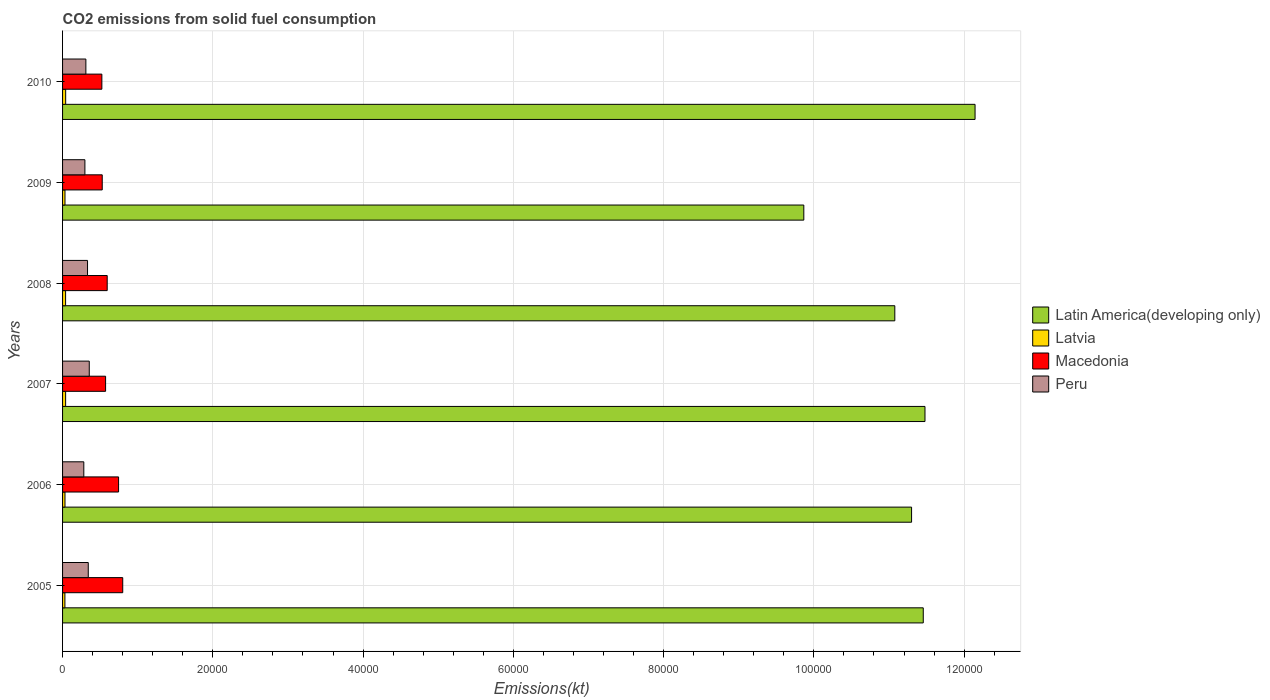How many different coloured bars are there?
Give a very brief answer. 4. Are the number of bars per tick equal to the number of legend labels?
Give a very brief answer. Yes. Are the number of bars on each tick of the Y-axis equal?
Provide a short and direct response. Yes. How many bars are there on the 1st tick from the top?
Your response must be concise. 4. What is the label of the 4th group of bars from the top?
Your answer should be compact. 2007. What is the amount of CO2 emitted in Latin America(developing only) in 2009?
Your answer should be very brief. 9.87e+04. Across all years, what is the maximum amount of CO2 emitted in Peru?
Offer a terse response. 3553.32. Across all years, what is the minimum amount of CO2 emitted in Peru?
Ensure brevity in your answer.  2827.26. In which year was the amount of CO2 emitted in Latin America(developing only) maximum?
Make the answer very short. 2010. What is the total amount of CO2 emitted in Peru in the graph?
Make the answer very short. 1.92e+04. What is the difference between the amount of CO2 emitted in Latin America(developing only) in 2005 and that in 2009?
Give a very brief answer. 1.59e+04. What is the difference between the amount of CO2 emitted in Macedonia in 2010 and the amount of CO2 emitted in Latvia in 2009?
Your response must be concise. 4906.45. What is the average amount of CO2 emitted in Latin America(developing only) per year?
Provide a succinct answer. 1.12e+05. In the year 2005, what is the difference between the amount of CO2 emitted in Latvia and amount of CO2 emitted in Latin America(developing only)?
Ensure brevity in your answer.  -1.14e+05. What is the ratio of the amount of CO2 emitted in Latvia in 2005 to that in 2006?
Keep it short and to the point. 0.97. Is the amount of CO2 emitted in Latin America(developing only) in 2006 less than that in 2009?
Your answer should be very brief. No. What is the difference between the highest and the second highest amount of CO2 emitted in Latin America(developing only)?
Ensure brevity in your answer.  6665.47. What is the difference between the highest and the lowest amount of CO2 emitted in Latvia?
Keep it short and to the point. 102.68. Is the sum of the amount of CO2 emitted in Latin America(developing only) in 2006 and 2009 greater than the maximum amount of CO2 emitted in Peru across all years?
Your response must be concise. Yes. Is it the case that in every year, the sum of the amount of CO2 emitted in Latvia and amount of CO2 emitted in Latin America(developing only) is greater than the sum of amount of CO2 emitted in Peru and amount of CO2 emitted in Macedonia?
Keep it short and to the point. No. What does the 4th bar from the top in 2009 represents?
Provide a short and direct response. Latin America(developing only). What does the 2nd bar from the bottom in 2009 represents?
Your answer should be compact. Latvia. Is it the case that in every year, the sum of the amount of CO2 emitted in Latin America(developing only) and amount of CO2 emitted in Macedonia is greater than the amount of CO2 emitted in Latvia?
Your answer should be compact. Yes. Are the values on the major ticks of X-axis written in scientific E-notation?
Give a very brief answer. No. Does the graph contain any zero values?
Give a very brief answer. No. How are the legend labels stacked?
Your answer should be compact. Vertical. What is the title of the graph?
Keep it short and to the point. CO2 emissions from solid fuel consumption. What is the label or title of the X-axis?
Offer a terse response. Emissions(kt). What is the Emissions(kt) in Latin America(developing only) in 2005?
Give a very brief answer. 1.15e+05. What is the Emissions(kt) of Latvia in 2005?
Your response must be concise. 311.69. What is the Emissions(kt) in Macedonia in 2005?
Provide a succinct answer. 8008.73. What is the Emissions(kt) of Peru in 2005?
Make the answer very short. 3421.31. What is the Emissions(kt) of Latin America(developing only) in 2006?
Provide a short and direct response. 1.13e+05. What is the Emissions(kt) in Latvia in 2006?
Give a very brief answer. 322.7. What is the Emissions(kt) in Macedonia in 2006?
Keep it short and to the point. 7455.01. What is the Emissions(kt) in Peru in 2006?
Your answer should be very brief. 2827.26. What is the Emissions(kt) of Latin America(developing only) in 2007?
Provide a short and direct response. 1.15e+05. What is the Emissions(kt) of Latvia in 2007?
Offer a very short reply. 407.04. What is the Emissions(kt) of Macedonia in 2007?
Your answer should be compact. 5727.85. What is the Emissions(kt) of Peru in 2007?
Ensure brevity in your answer.  3553.32. What is the Emissions(kt) of Latin America(developing only) in 2008?
Keep it short and to the point. 1.11e+05. What is the Emissions(kt) of Latvia in 2008?
Keep it short and to the point. 403.37. What is the Emissions(kt) in Macedonia in 2008?
Make the answer very short. 5940.54. What is the Emissions(kt) in Peru in 2008?
Offer a terse response. 3322.3. What is the Emissions(kt) of Latin America(developing only) in 2009?
Keep it short and to the point. 9.87e+04. What is the Emissions(kt) of Latvia in 2009?
Offer a very short reply. 322.7. What is the Emissions(kt) of Macedonia in 2009?
Keep it short and to the point. 5280.48. What is the Emissions(kt) of Peru in 2009?
Offer a very short reply. 2973.94. What is the Emissions(kt) of Latin America(developing only) in 2010?
Ensure brevity in your answer.  1.21e+05. What is the Emissions(kt) in Latvia in 2010?
Provide a short and direct response. 414.37. What is the Emissions(kt) of Macedonia in 2010?
Offer a terse response. 5229.14. What is the Emissions(kt) in Peru in 2010?
Keep it short and to the point. 3102.28. Across all years, what is the maximum Emissions(kt) in Latin America(developing only)?
Ensure brevity in your answer.  1.21e+05. Across all years, what is the maximum Emissions(kt) of Latvia?
Make the answer very short. 414.37. Across all years, what is the maximum Emissions(kt) of Macedonia?
Your answer should be very brief. 8008.73. Across all years, what is the maximum Emissions(kt) of Peru?
Offer a very short reply. 3553.32. Across all years, what is the minimum Emissions(kt) in Latin America(developing only)?
Keep it short and to the point. 9.87e+04. Across all years, what is the minimum Emissions(kt) in Latvia?
Make the answer very short. 311.69. Across all years, what is the minimum Emissions(kt) of Macedonia?
Offer a very short reply. 5229.14. Across all years, what is the minimum Emissions(kt) of Peru?
Your response must be concise. 2827.26. What is the total Emissions(kt) of Latin America(developing only) in the graph?
Give a very brief answer. 6.73e+05. What is the total Emissions(kt) of Latvia in the graph?
Keep it short and to the point. 2181.86. What is the total Emissions(kt) in Macedonia in the graph?
Offer a terse response. 3.76e+04. What is the total Emissions(kt) in Peru in the graph?
Keep it short and to the point. 1.92e+04. What is the difference between the Emissions(kt) of Latin America(developing only) in 2005 and that in 2006?
Keep it short and to the point. 1556.24. What is the difference between the Emissions(kt) of Latvia in 2005 and that in 2006?
Make the answer very short. -11. What is the difference between the Emissions(kt) in Macedonia in 2005 and that in 2006?
Keep it short and to the point. 553.72. What is the difference between the Emissions(kt) of Peru in 2005 and that in 2006?
Ensure brevity in your answer.  594.05. What is the difference between the Emissions(kt) in Latin America(developing only) in 2005 and that in 2007?
Your response must be concise. -227.8. What is the difference between the Emissions(kt) of Latvia in 2005 and that in 2007?
Offer a terse response. -95.34. What is the difference between the Emissions(kt) of Macedonia in 2005 and that in 2007?
Your response must be concise. 2280.87. What is the difference between the Emissions(kt) of Peru in 2005 and that in 2007?
Give a very brief answer. -132.01. What is the difference between the Emissions(kt) in Latin America(developing only) in 2005 and that in 2008?
Give a very brief answer. 3788.18. What is the difference between the Emissions(kt) of Latvia in 2005 and that in 2008?
Your response must be concise. -91.67. What is the difference between the Emissions(kt) of Macedonia in 2005 and that in 2008?
Make the answer very short. 2068.19. What is the difference between the Emissions(kt) in Peru in 2005 and that in 2008?
Keep it short and to the point. 99.01. What is the difference between the Emissions(kt) in Latin America(developing only) in 2005 and that in 2009?
Give a very brief answer. 1.59e+04. What is the difference between the Emissions(kt) in Latvia in 2005 and that in 2009?
Provide a succinct answer. -11. What is the difference between the Emissions(kt) in Macedonia in 2005 and that in 2009?
Provide a short and direct response. 2728.25. What is the difference between the Emissions(kt) of Peru in 2005 and that in 2009?
Keep it short and to the point. 447.37. What is the difference between the Emissions(kt) of Latin America(developing only) in 2005 and that in 2010?
Give a very brief answer. -6893.27. What is the difference between the Emissions(kt) of Latvia in 2005 and that in 2010?
Provide a succinct answer. -102.68. What is the difference between the Emissions(kt) in Macedonia in 2005 and that in 2010?
Provide a short and direct response. 2779.59. What is the difference between the Emissions(kt) in Peru in 2005 and that in 2010?
Provide a succinct answer. 319.03. What is the difference between the Emissions(kt) in Latin America(developing only) in 2006 and that in 2007?
Your answer should be compact. -1784.04. What is the difference between the Emissions(kt) in Latvia in 2006 and that in 2007?
Give a very brief answer. -84.34. What is the difference between the Emissions(kt) in Macedonia in 2006 and that in 2007?
Offer a very short reply. 1727.16. What is the difference between the Emissions(kt) in Peru in 2006 and that in 2007?
Provide a succinct answer. -726.07. What is the difference between the Emissions(kt) of Latin America(developing only) in 2006 and that in 2008?
Your response must be concise. 2231.94. What is the difference between the Emissions(kt) of Latvia in 2006 and that in 2008?
Your answer should be compact. -80.67. What is the difference between the Emissions(kt) in Macedonia in 2006 and that in 2008?
Keep it short and to the point. 1514.47. What is the difference between the Emissions(kt) in Peru in 2006 and that in 2008?
Your answer should be very brief. -495.05. What is the difference between the Emissions(kt) in Latin America(developing only) in 2006 and that in 2009?
Your answer should be very brief. 1.43e+04. What is the difference between the Emissions(kt) of Latvia in 2006 and that in 2009?
Your answer should be compact. 0. What is the difference between the Emissions(kt) in Macedonia in 2006 and that in 2009?
Make the answer very short. 2174.53. What is the difference between the Emissions(kt) of Peru in 2006 and that in 2009?
Provide a short and direct response. -146.68. What is the difference between the Emissions(kt) of Latin America(developing only) in 2006 and that in 2010?
Give a very brief answer. -8449.5. What is the difference between the Emissions(kt) of Latvia in 2006 and that in 2010?
Provide a short and direct response. -91.67. What is the difference between the Emissions(kt) in Macedonia in 2006 and that in 2010?
Ensure brevity in your answer.  2225.87. What is the difference between the Emissions(kt) in Peru in 2006 and that in 2010?
Provide a short and direct response. -275.02. What is the difference between the Emissions(kt) of Latin America(developing only) in 2007 and that in 2008?
Give a very brief answer. 4015.98. What is the difference between the Emissions(kt) in Latvia in 2007 and that in 2008?
Offer a terse response. 3.67. What is the difference between the Emissions(kt) of Macedonia in 2007 and that in 2008?
Give a very brief answer. -212.69. What is the difference between the Emissions(kt) of Peru in 2007 and that in 2008?
Offer a terse response. 231.02. What is the difference between the Emissions(kt) of Latin America(developing only) in 2007 and that in 2009?
Make the answer very short. 1.61e+04. What is the difference between the Emissions(kt) of Latvia in 2007 and that in 2009?
Ensure brevity in your answer.  84.34. What is the difference between the Emissions(kt) of Macedonia in 2007 and that in 2009?
Keep it short and to the point. 447.37. What is the difference between the Emissions(kt) in Peru in 2007 and that in 2009?
Provide a succinct answer. 579.39. What is the difference between the Emissions(kt) in Latin America(developing only) in 2007 and that in 2010?
Offer a very short reply. -6665.47. What is the difference between the Emissions(kt) in Latvia in 2007 and that in 2010?
Offer a very short reply. -7.33. What is the difference between the Emissions(kt) of Macedonia in 2007 and that in 2010?
Make the answer very short. 498.71. What is the difference between the Emissions(kt) of Peru in 2007 and that in 2010?
Your answer should be very brief. 451.04. What is the difference between the Emissions(kt) of Latin America(developing only) in 2008 and that in 2009?
Ensure brevity in your answer.  1.21e+04. What is the difference between the Emissions(kt) of Latvia in 2008 and that in 2009?
Your answer should be compact. 80.67. What is the difference between the Emissions(kt) in Macedonia in 2008 and that in 2009?
Your answer should be very brief. 660.06. What is the difference between the Emissions(kt) of Peru in 2008 and that in 2009?
Provide a short and direct response. 348.37. What is the difference between the Emissions(kt) in Latin America(developing only) in 2008 and that in 2010?
Your answer should be compact. -1.07e+04. What is the difference between the Emissions(kt) of Latvia in 2008 and that in 2010?
Provide a succinct answer. -11. What is the difference between the Emissions(kt) of Macedonia in 2008 and that in 2010?
Your answer should be very brief. 711.4. What is the difference between the Emissions(kt) of Peru in 2008 and that in 2010?
Provide a succinct answer. 220.02. What is the difference between the Emissions(kt) in Latin America(developing only) in 2009 and that in 2010?
Your answer should be compact. -2.28e+04. What is the difference between the Emissions(kt) in Latvia in 2009 and that in 2010?
Provide a short and direct response. -91.67. What is the difference between the Emissions(kt) of Macedonia in 2009 and that in 2010?
Your answer should be compact. 51.34. What is the difference between the Emissions(kt) of Peru in 2009 and that in 2010?
Make the answer very short. -128.34. What is the difference between the Emissions(kt) of Latin America(developing only) in 2005 and the Emissions(kt) of Latvia in 2006?
Give a very brief answer. 1.14e+05. What is the difference between the Emissions(kt) in Latin America(developing only) in 2005 and the Emissions(kt) in Macedonia in 2006?
Offer a terse response. 1.07e+05. What is the difference between the Emissions(kt) of Latin America(developing only) in 2005 and the Emissions(kt) of Peru in 2006?
Your response must be concise. 1.12e+05. What is the difference between the Emissions(kt) of Latvia in 2005 and the Emissions(kt) of Macedonia in 2006?
Provide a short and direct response. -7143.32. What is the difference between the Emissions(kt) in Latvia in 2005 and the Emissions(kt) in Peru in 2006?
Ensure brevity in your answer.  -2515.56. What is the difference between the Emissions(kt) of Macedonia in 2005 and the Emissions(kt) of Peru in 2006?
Offer a terse response. 5181.47. What is the difference between the Emissions(kt) in Latin America(developing only) in 2005 and the Emissions(kt) in Latvia in 2007?
Provide a short and direct response. 1.14e+05. What is the difference between the Emissions(kt) of Latin America(developing only) in 2005 and the Emissions(kt) of Macedonia in 2007?
Keep it short and to the point. 1.09e+05. What is the difference between the Emissions(kt) of Latin America(developing only) in 2005 and the Emissions(kt) of Peru in 2007?
Ensure brevity in your answer.  1.11e+05. What is the difference between the Emissions(kt) in Latvia in 2005 and the Emissions(kt) in Macedonia in 2007?
Ensure brevity in your answer.  -5416.16. What is the difference between the Emissions(kt) of Latvia in 2005 and the Emissions(kt) of Peru in 2007?
Offer a very short reply. -3241.63. What is the difference between the Emissions(kt) in Macedonia in 2005 and the Emissions(kt) in Peru in 2007?
Offer a terse response. 4455.4. What is the difference between the Emissions(kt) of Latin America(developing only) in 2005 and the Emissions(kt) of Latvia in 2008?
Offer a very short reply. 1.14e+05. What is the difference between the Emissions(kt) of Latin America(developing only) in 2005 and the Emissions(kt) of Macedonia in 2008?
Provide a succinct answer. 1.09e+05. What is the difference between the Emissions(kt) of Latin America(developing only) in 2005 and the Emissions(kt) of Peru in 2008?
Offer a terse response. 1.11e+05. What is the difference between the Emissions(kt) in Latvia in 2005 and the Emissions(kt) in Macedonia in 2008?
Offer a very short reply. -5628.85. What is the difference between the Emissions(kt) in Latvia in 2005 and the Emissions(kt) in Peru in 2008?
Ensure brevity in your answer.  -3010.61. What is the difference between the Emissions(kt) in Macedonia in 2005 and the Emissions(kt) in Peru in 2008?
Ensure brevity in your answer.  4686.43. What is the difference between the Emissions(kt) in Latin America(developing only) in 2005 and the Emissions(kt) in Latvia in 2009?
Provide a succinct answer. 1.14e+05. What is the difference between the Emissions(kt) in Latin America(developing only) in 2005 and the Emissions(kt) in Macedonia in 2009?
Give a very brief answer. 1.09e+05. What is the difference between the Emissions(kt) of Latin America(developing only) in 2005 and the Emissions(kt) of Peru in 2009?
Your answer should be very brief. 1.12e+05. What is the difference between the Emissions(kt) of Latvia in 2005 and the Emissions(kt) of Macedonia in 2009?
Keep it short and to the point. -4968.78. What is the difference between the Emissions(kt) of Latvia in 2005 and the Emissions(kt) of Peru in 2009?
Ensure brevity in your answer.  -2662.24. What is the difference between the Emissions(kt) of Macedonia in 2005 and the Emissions(kt) of Peru in 2009?
Offer a terse response. 5034.79. What is the difference between the Emissions(kt) of Latin America(developing only) in 2005 and the Emissions(kt) of Latvia in 2010?
Keep it short and to the point. 1.14e+05. What is the difference between the Emissions(kt) in Latin America(developing only) in 2005 and the Emissions(kt) in Macedonia in 2010?
Make the answer very short. 1.09e+05. What is the difference between the Emissions(kt) of Latin America(developing only) in 2005 and the Emissions(kt) of Peru in 2010?
Provide a short and direct response. 1.11e+05. What is the difference between the Emissions(kt) of Latvia in 2005 and the Emissions(kt) of Macedonia in 2010?
Give a very brief answer. -4917.45. What is the difference between the Emissions(kt) of Latvia in 2005 and the Emissions(kt) of Peru in 2010?
Offer a terse response. -2790.59. What is the difference between the Emissions(kt) of Macedonia in 2005 and the Emissions(kt) of Peru in 2010?
Your answer should be very brief. 4906.45. What is the difference between the Emissions(kt) in Latin America(developing only) in 2006 and the Emissions(kt) in Latvia in 2007?
Your answer should be compact. 1.13e+05. What is the difference between the Emissions(kt) of Latin America(developing only) in 2006 and the Emissions(kt) of Macedonia in 2007?
Make the answer very short. 1.07e+05. What is the difference between the Emissions(kt) of Latin America(developing only) in 2006 and the Emissions(kt) of Peru in 2007?
Your answer should be compact. 1.09e+05. What is the difference between the Emissions(kt) in Latvia in 2006 and the Emissions(kt) in Macedonia in 2007?
Provide a short and direct response. -5405.16. What is the difference between the Emissions(kt) in Latvia in 2006 and the Emissions(kt) in Peru in 2007?
Give a very brief answer. -3230.63. What is the difference between the Emissions(kt) in Macedonia in 2006 and the Emissions(kt) in Peru in 2007?
Your response must be concise. 3901.69. What is the difference between the Emissions(kt) in Latin America(developing only) in 2006 and the Emissions(kt) in Latvia in 2008?
Offer a terse response. 1.13e+05. What is the difference between the Emissions(kt) of Latin America(developing only) in 2006 and the Emissions(kt) of Macedonia in 2008?
Offer a very short reply. 1.07e+05. What is the difference between the Emissions(kt) of Latin America(developing only) in 2006 and the Emissions(kt) of Peru in 2008?
Ensure brevity in your answer.  1.10e+05. What is the difference between the Emissions(kt) in Latvia in 2006 and the Emissions(kt) in Macedonia in 2008?
Give a very brief answer. -5617.84. What is the difference between the Emissions(kt) in Latvia in 2006 and the Emissions(kt) in Peru in 2008?
Offer a terse response. -2999.61. What is the difference between the Emissions(kt) in Macedonia in 2006 and the Emissions(kt) in Peru in 2008?
Your answer should be compact. 4132.71. What is the difference between the Emissions(kt) of Latin America(developing only) in 2006 and the Emissions(kt) of Latvia in 2009?
Your answer should be compact. 1.13e+05. What is the difference between the Emissions(kt) in Latin America(developing only) in 2006 and the Emissions(kt) in Macedonia in 2009?
Give a very brief answer. 1.08e+05. What is the difference between the Emissions(kt) of Latin America(developing only) in 2006 and the Emissions(kt) of Peru in 2009?
Keep it short and to the point. 1.10e+05. What is the difference between the Emissions(kt) of Latvia in 2006 and the Emissions(kt) of Macedonia in 2009?
Ensure brevity in your answer.  -4957.78. What is the difference between the Emissions(kt) of Latvia in 2006 and the Emissions(kt) of Peru in 2009?
Your answer should be compact. -2651.24. What is the difference between the Emissions(kt) in Macedonia in 2006 and the Emissions(kt) in Peru in 2009?
Provide a succinct answer. 4481.07. What is the difference between the Emissions(kt) of Latin America(developing only) in 2006 and the Emissions(kt) of Latvia in 2010?
Make the answer very short. 1.13e+05. What is the difference between the Emissions(kt) in Latin America(developing only) in 2006 and the Emissions(kt) in Macedonia in 2010?
Offer a terse response. 1.08e+05. What is the difference between the Emissions(kt) of Latin America(developing only) in 2006 and the Emissions(kt) of Peru in 2010?
Keep it short and to the point. 1.10e+05. What is the difference between the Emissions(kt) in Latvia in 2006 and the Emissions(kt) in Macedonia in 2010?
Provide a short and direct response. -4906.45. What is the difference between the Emissions(kt) of Latvia in 2006 and the Emissions(kt) of Peru in 2010?
Give a very brief answer. -2779.59. What is the difference between the Emissions(kt) of Macedonia in 2006 and the Emissions(kt) of Peru in 2010?
Offer a very short reply. 4352.73. What is the difference between the Emissions(kt) in Latin America(developing only) in 2007 and the Emissions(kt) in Latvia in 2008?
Your answer should be compact. 1.14e+05. What is the difference between the Emissions(kt) of Latin America(developing only) in 2007 and the Emissions(kt) of Macedonia in 2008?
Your answer should be very brief. 1.09e+05. What is the difference between the Emissions(kt) of Latin America(developing only) in 2007 and the Emissions(kt) of Peru in 2008?
Provide a succinct answer. 1.11e+05. What is the difference between the Emissions(kt) in Latvia in 2007 and the Emissions(kt) in Macedonia in 2008?
Your answer should be compact. -5533.5. What is the difference between the Emissions(kt) of Latvia in 2007 and the Emissions(kt) of Peru in 2008?
Your answer should be very brief. -2915.26. What is the difference between the Emissions(kt) of Macedonia in 2007 and the Emissions(kt) of Peru in 2008?
Offer a very short reply. 2405.55. What is the difference between the Emissions(kt) in Latin America(developing only) in 2007 and the Emissions(kt) in Latvia in 2009?
Provide a short and direct response. 1.14e+05. What is the difference between the Emissions(kt) of Latin America(developing only) in 2007 and the Emissions(kt) of Macedonia in 2009?
Give a very brief answer. 1.10e+05. What is the difference between the Emissions(kt) of Latin America(developing only) in 2007 and the Emissions(kt) of Peru in 2009?
Offer a very short reply. 1.12e+05. What is the difference between the Emissions(kt) in Latvia in 2007 and the Emissions(kt) in Macedonia in 2009?
Your answer should be compact. -4873.44. What is the difference between the Emissions(kt) of Latvia in 2007 and the Emissions(kt) of Peru in 2009?
Your answer should be compact. -2566.9. What is the difference between the Emissions(kt) of Macedonia in 2007 and the Emissions(kt) of Peru in 2009?
Make the answer very short. 2753.92. What is the difference between the Emissions(kt) in Latin America(developing only) in 2007 and the Emissions(kt) in Latvia in 2010?
Your answer should be compact. 1.14e+05. What is the difference between the Emissions(kt) of Latin America(developing only) in 2007 and the Emissions(kt) of Macedonia in 2010?
Make the answer very short. 1.10e+05. What is the difference between the Emissions(kt) of Latin America(developing only) in 2007 and the Emissions(kt) of Peru in 2010?
Your answer should be very brief. 1.12e+05. What is the difference between the Emissions(kt) in Latvia in 2007 and the Emissions(kt) in Macedonia in 2010?
Your answer should be very brief. -4822.1. What is the difference between the Emissions(kt) of Latvia in 2007 and the Emissions(kt) of Peru in 2010?
Offer a very short reply. -2695.24. What is the difference between the Emissions(kt) of Macedonia in 2007 and the Emissions(kt) of Peru in 2010?
Your answer should be very brief. 2625.57. What is the difference between the Emissions(kt) in Latin America(developing only) in 2008 and the Emissions(kt) in Latvia in 2009?
Offer a very short reply. 1.10e+05. What is the difference between the Emissions(kt) of Latin America(developing only) in 2008 and the Emissions(kt) of Macedonia in 2009?
Offer a very short reply. 1.05e+05. What is the difference between the Emissions(kt) of Latin America(developing only) in 2008 and the Emissions(kt) of Peru in 2009?
Make the answer very short. 1.08e+05. What is the difference between the Emissions(kt) in Latvia in 2008 and the Emissions(kt) in Macedonia in 2009?
Keep it short and to the point. -4877.11. What is the difference between the Emissions(kt) of Latvia in 2008 and the Emissions(kt) of Peru in 2009?
Make the answer very short. -2570.57. What is the difference between the Emissions(kt) of Macedonia in 2008 and the Emissions(kt) of Peru in 2009?
Give a very brief answer. 2966.6. What is the difference between the Emissions(kt) of Latin America(developing only) in 2008 and the Emissions(kt) of Latvia in 2010?
Provide a short and direct response. 1.10e+05. What is the difference between the Emissions(kt) in Latin America(developing only) in 2008 and the Emissions(kt) in Macedonia in 2010?
Your response must be concise. 1.06e+05. What is the difference between the Emissions(kt) in Latin America(developing only) in 2008 and the Emissions(kt) in Peru in 2010?
Offer a very short reply. 1.08e+05. What is the difference between the Emissions(kt) in Latvia in 2008 and the Emissions(kt) in Macedonia in 2010?
Make the answer very short. -4825.77. What is the difference between the Emissions(kt) in Latvia in 2008 and the Emissions(kt) in Peru in 2010?
Your answer should be compact. -2698.91. What is the difference between the Emissions(kt) in Macedonia in 2008 and the Emissions(kt) in Peru in 2010?
Offer a very short reply. 2838.26. What is the difference between the Emissions(kt) in Latin America(developing only) in 2009 and the Emissions(kt) in Latvia in 2010?
Give a very brief answer. 9.82e+04. What is the difference between the Emissions(kt) of Latin America(developing only) in 2009 and the Emissions(kt) of Macedonia in 2010?
Your answer should be very brief. 9.34e+04. What is the difference between the Emissions(kt) in Latin America(developing only) in 2009 and the Emissions(kt) in Peru in 2010?
Your answer should be compact. 9.56e+04. What is the difference between the Emissions(kt) of Latvia in 2009 and the Emissions(kt) of Macedonia in 2010?
Your response must be concise. -4906.45. What is the difference between the Emissions(kt) of Latvia in 2009 and the Emissions(kt) of Peru in 2010?
Provide a succinct answer. -2779.59. What is the difference between the Emissions(kt) of Macedonia in 2009 and the Emissions(kt) of Peru in 2010?
Your response must be concise. 2178.2. What is the average Emissions(kt) of Latin America(developing only) per year?
Keep it short and to the point. 1.12e+05. What is the average Emissions(kt) of Latvia per year?
Provide a short and direct response. 363.64. What is the average Emissions(kt) of Macedonia per year?
Ensure brevity in your answer.  6273.63. What is the average Emissions(kt) in Peru per year?
Your answer should be very brief. 3200.07. In the year 2005, what is the difference between the Emissions(kt) of Latin America(developing only) and Emissions(kt) of Latvia?
Keep it short and to the point. 1.14e+05. In the year 2005, what is the difference between the Emissions(kt) in Latin America(developing only) and Emissions(kt) in Macedonia?
Make the answer very short. 1.07e+05. In the year 2005, what is the difference between the Emissions(kt) of Latin America(developing only) and Emissions(kt) of Peru?
Provide a succinct answer. 1.11e+05. In the year 2005, what is the difference between the Emissions(kt) in Latvia and Emissions(kt) in Macedonia?
Make the answer very short. -7697.03. In the year 2005, what is the difference between the Emissions(kt) in Latvia and Emissions(kt) in Peru?
Offer a very short reply. -3109.62. In the year 2005, what is the difference between the Emissions(kt) of Macedonia and Emissions(kt) of Peru?
Keep it short and to the point. 4587.42. In the year 2006, what is the difference between the Emissions(kt) in Latin America(developing only) and Emissions(kt) in Latvia?
Make the answer very short. 1.13e+05. In the year 2006, what is the difference between the Emissions(kt) of Latin America(developing only) and Emissions(kt) of Macedonia?
Your answer should be compact. 1.06e+05. In the year 2006, what is the difference between the Emissions(kt) of Latin America(developing only) and Emissions(kt) of Peru?
Your response must be concise. 1.10e+05. In the year 2006, what is the difference between the Emissions(kt) of Latvia and Emissions(kt) of Macedonia?
Your response must be concise. -7132.31. In the year 2006, what is the difference between the Emissions(kt) of Latvia and Emissions(kt) of Peru?
Keep it short and to the point. -2504.56. In the year 2006, what is the difference between the Emissions(kt) of Macedonia and Emissions(kt) of Peru?
Provide a succinct answer. 4627.75. In the year 2007, what is the difference between the Emissions(kt) of Latin America(developing only) and Emissions(kt) of Latvia?
Give a very brief answer. 1.14e+05. In the year 2007, what is the difference between the Emissions(kt) of Latin America(developing only) and Emissions(kt) of Macedonia?
Provide a short and direct response. 1.09e+05. In the year 2007, what is the difference between the Emissions(kt) of Latin America(developing only) and Emissions(kt) of Peru?
Provide a succinct answer. 1.11e+05. In the year 2007, what is the difference between the Emissions(kt) in Latvia and Emissions(kt) in Macedonia?
Offer a very short reply. -5320.82. In the year 2007, what is the difference between the Emissions(kt) in Latvia and Emissions(kt) in Peru?
Provide a succinct answer. -3146.29. In the year 2007, what is the difference between the Emissions(kt) in Macedonia and Emissions(kt) in Peru?
Your response must be concise. 2174.53. In the year 2008, what is the difference between the Emissions(kt) in Latin America(developing only) and Emissions(kt) in Latvia?
Give a very brief answer. 1.10e+05. In the year 2008, what is the difference between the Emissions(kt) in Latin America(developing only) and Emissions(kt) in Macedonia?
Make the answer very short. 1.05e+05. In the year 2008, what is the difference between the Emissions(kt) of Latin America(developing only) and Emissions(kt) of Peru?
Provide a succinct answer. 1.07e+05. In the year 2008, what is the difference between the Emissions(kt) of Latvia and Emissions(kt) of Macedonia?
Your answer should be compact. -5537.17. In the year 2008, what is the difference between the Emissions(kt) of Latvia and Emissions(kt) of Peru?
Keep it short and to the point. -2918.93. In the year 2008, what is the difference between the Emissions(kt) of Macedonia and Emissions(kt) of Peru?
Ensure brevity in your answer.  2618.24. In the year 2009, what is the difference between the Emissions(kt) in Latin America(developing only) and Emissions(kt) in Latvia?
Give a very brief answer. 9.83e+04. In the year 2009, what is the difference between the Emissions(kt) in Latin America(developing only) and Emissions(kt) in Macedonia?
Provide a short and direct response. 9.34e+04. In the year 2009, what is the difference between the Emissions(kt) of Latin America(developing only) and Emissions(kt) of Peru?
Provide a short and direct response. 9.57e+04. In the year 2009, what is the difference between the Emissions(kt) in Latvia and Emissions(kt) in Macedonia?
Keep it short and to the point. -4957.78. In the year 2009, what is the difference between the Emissions(kt) in Latvia and Emissions(kt) in Peru?
Ensure brevity in your answer.  -2651.24. In the year 2009, what is the difference between the Emissions(kt) of Macedonia and Emissions(kt) of Peru?
Provide a short and direct response. 2306.54. In the year 2010, what is the difference between the Emissions(kt) of Latin America(developing only) and Emissions(kt) of Latvia?
Give a very brief answer. 1.21e+05. In the year 2010, what is the difference between the Emissions(kt) of Latin America(developing only) and Emissions(kt) of Macedonia?
Provide a succinct answer. 1.16e+05. In the year 2010, what is the difference between the Emissions(kt) in Latin America(developing only) and Emissions(kt) in Peru?
Make the answer very short. 1.18e+05. In the year 2010, what is the difference between the Emissions(kt) of Latvia and Emissions(kt) of Macedonia?
Your answer should be very brief. -4814.77. In the year 2010, what is the difference between the Emissions(kt) of Latvia and Emissions(kt) of Peru?
Ensure brevity in your answer.  -2687.91. In the year 2010, what is the difference between the Emissions(kt) in Macedonia and Emissions(kt) in Peru?
Ensure brevity in your answer.  2126.86. What is the ratio of the Emissions(kt) of Latin America(developing only) in 2005 to that in 2006?
Your answer should be very brief. 1.01. What is the ratio of the Emissions(kt) in Latvia in 2005 to that in 2006?
Provide a short and direct response. 0.97. What is the ratio of the Emissions(kt) of Macedonia in 2005 to that in 2006?
Your response must be concise. 1.07. What is the ratio of the Emissions(kt) of Peru in 2005 to that in 2006?
Offer a very short reply. 1.21. What is the ratio of the Emissions(kt) of Latin America(developing only) in 2005 to that in 2007?
Give a very brief answer. 1. What is the ratio of the Emissions(kt) of Latvia in 2005 to that in 2007?
Give a very brief answer. 0.77. What is the ratio of the Emissions(kt) of Macedonia in 2005 to that in 2007?
Make the answer very short. 1.4. What is the ratio of the Emissions(kt) of Peru in 2005 to that in 2007?
Ensure brevity in your answer.  0.96. What is the ratio of the Emissions(kt) in Latin America(developing only) in 2005 to that in 2008?
Your response must be concise. 1.03. What is the ratio of the Emissions(kt) of Latvia in 2005 to that in 2008?
Keep it short and to the point. 0.77. What is the ratio of the Emissions(kt) in Macedonia in 2005 to that in 2008?
Offer a terse response. 1.35. What is the ratio of the Emissions(kt) of Peru in 2005 to that in 2008?
Provide a short and direct response. 1.03. What is the ratio of the Emissions(kt) of Latin America(developing only) in 2005 to that in 2009?
Offer a very short reply. 1.16. What is the ratio of the Emissions(kt) in Latvia in 2005 to that in 2009?
Your answer should be compact. 0.97. What is the ratio of the Emissions(kt) in Macedonia in 2005 to that in 2009?
Make the answer very short. 1.52. What is the ratio of the Emissions(kt) in Peru in 2005 to that in 2009?
Your answer should be compact. 1.15. What is the ratio of the Emissions(kt) of Latin America(developing only) in 2005 to that in 2010?
Offer a very short reply. 0.94. What is the ratio of the Emissions(kt) of Latvia in 2005 to that in 2010?
Your answer should be compact. 0.75. What is the ratio of the Emissions(kt) in Macedonia in 2005 to that in 2010?
Your answer should be very brief. 1.53. What is the ratio of the Emissions(kt) in Peru in 2005 to that in 2010?
Offer a terse response. 1.1. What is the ratio of the Emissions(kt) of Latin America(developing only) in 2006 to that in 2007?
Your response must be concise. 0.98. What is the ratio of the Emissions(kt) of Latvia in 2006 to that in 2007?
Provide a short and direct response. 0.79. What is the ratio of the Emissions(kt) of Macedonia in 2006 to that in 2007?
Your response must be concise. 1.3. What is the ratio of the Emissions(kt) of Peru in 2006 to that in 2007?
Provide a succinct answer. 0.8. What is the ratio of the Emissions(kt) in Latin America(developing only) in 2006 to that in 2008?
Offer a terse response. 1.02. What is the ratio of the Emissions(kt) of Macedonia in 2006 to that in 2008?
Provide a short and direct response. 1.25. What is the ratio of the Emissions(kt) in Peru in 2006 to that in 2008?
Offer a very short reply. 0.85. What is the ratio of the Emissions(kt) of Latin America(developing only) in 2006 to that in 2009?
Your answer should be compact. 1.15. What is the ratio of the Emissions(kt) in Latvia in 2006 to that in 2009?
Give a very brief answer. 1. What is the ratio of the Emissions(kt) in Macedonia in 2006 to that in 2009?
Your response must be concise. 1.41. What is the ratio of the Emissions(kt) in Peru in 2006 to that in 2009?
Your response must be concise. 0.95. What is the ratio of the Emissions(kt) of Latin America(developing only) in 2006 to that in 2010?
Provide a succinct answer. 0.93. What is the ratio of the Emissions(kt) of Latvia in 2006 to that in 2010?
Keep it short and to the point. 0.78. What is the ratio of the Emissions(kt) in Macedonia in 2006 to that in 2010?
Offer a terse response. 1.43. What is the ratio of the Emissions(kt) in Peru in 2006 to that in 2010?
Offer a terse response. 0.91. What is the ratio of the Emissions(kt) of Latin America(developing only) in 2007 to that in 2008?
Provide a short and direct response. 1.04. What is the ratio of the Emissions(kt) in Latvia in 2007 to that in 2008?
Offer a very short reply. 1.01. What is the ratio of the Emissions(kt) in Macedonia in 2007 to that in 2008?
Make the answer very short. 0.96. What is the ratio of the Emissions(kt) in Peru in 2007 to that in 2008?
Provide a short and direct response. 1.07. What is the ratio of the Emissions(kt) in Latin America(developing only) in 2007 to that in 2009?
Offer a terse response. 1.16. What is the ratio of the Emissions(kt) of Latvia in 2007 to that in 2009?
Your answer should be very brief. 1.26. What is the ratio of the Emissions(kt) in Macedonia in 2007 to that in 2009?
Your answer should be very brief. 1.08. What is the ratio of the Emissions(kt) in Peru in 2007 to that in 2009?
Make the answer very short. 1.19. What is the ratio of the Emissions(kt) in Latin America(developing only) in 2007 to that in 2010?
Offer a very short reply. 0.95. What is the ratio of the Emissions(kt) of Latvia in 2007 to that in 2010?
Offer a very short reply. 0.98. What is the ratio of the Emissions(kt) of Macedonia in 2007 to that in 2010?
Your answer should be very brief. 1.1. What is the ratio of the Emissions(kt) of Peru in 2007 to that in 2010?
Keep it short and to the point. 1.15. What is the ratio of the Emissions(kt) in Latin America(developing only) in 2008 to that in 2009?
Provide a short and direct response. 1.12. What is the ratio of the Emissions(kt) of Peru in 2008 to that in 2009?
Offer a terse response. 1.12. What is the ratio of the Emissions(kt) in Latin America(developing only) in 2008 to that in 2010?
Give a very brief answer. 0.91. What is the ratio of the Emissions(kt) in Latvia in 2008 to that in 2010?
Make the answer very short. 0.97. What is the ratio of the Emissions(kt) of Macedonia in 2008 to that in 2010?
Offer a terse response. 1.14. What is the ratio of the Emissions(kt) in Peru in 2008 to that in 2010?
Keep it short and to the point. 1.07. What is the ratio of the Emissions(kt) in Latin America(developing only) in 2009 to that in 2010?
Your response must be concise. 0.81. What is the ratio of the Emissions(kt) of Latvia in 2009 to that in 2010?
Your response must be concise. 0.78. What is the ratio of the Emissions(kt) of Macedonia in 2009 to that in 2010?
Your answer should be compact. 1.01. What is the ratio of the Emissions(kt) in Peru in 2009 to that in 2010?
Provide a succinct answer. 0.96. What is the difference between the highest and the second highest Emissions(kt) of Latin America(developing only)?
Provide a succinct answer. 6665.47. What is the difference between the highest and the second highest Emissions(kt) of Latvia?
Your answer should be compact. 7.33. What is the difference between the highest and the second highest Emissions(kt) of Macedonia?
Offer a terse response. 553.72. What is the difference between the highest and the second highest Emissions(kt) in Peru?
Make the answer very short. 132.01. What is the difference between the highest and the lowest Emissions(kt) in Latin America(developing only)?
Provide a succinct answer. 2.28e+04. What is the difference between the highest and the lowest Emissions(kt) in Latvia?
Provide a short and direct response. 102.68. What is the difference between the highest and the lowest Emissions(kt) of Macedonia?
Your answer should be compact. 2779.59. What is the difference between the highest and the lowest Emissions(kt) in Peru?
Your answer should be compact. 726.07. 